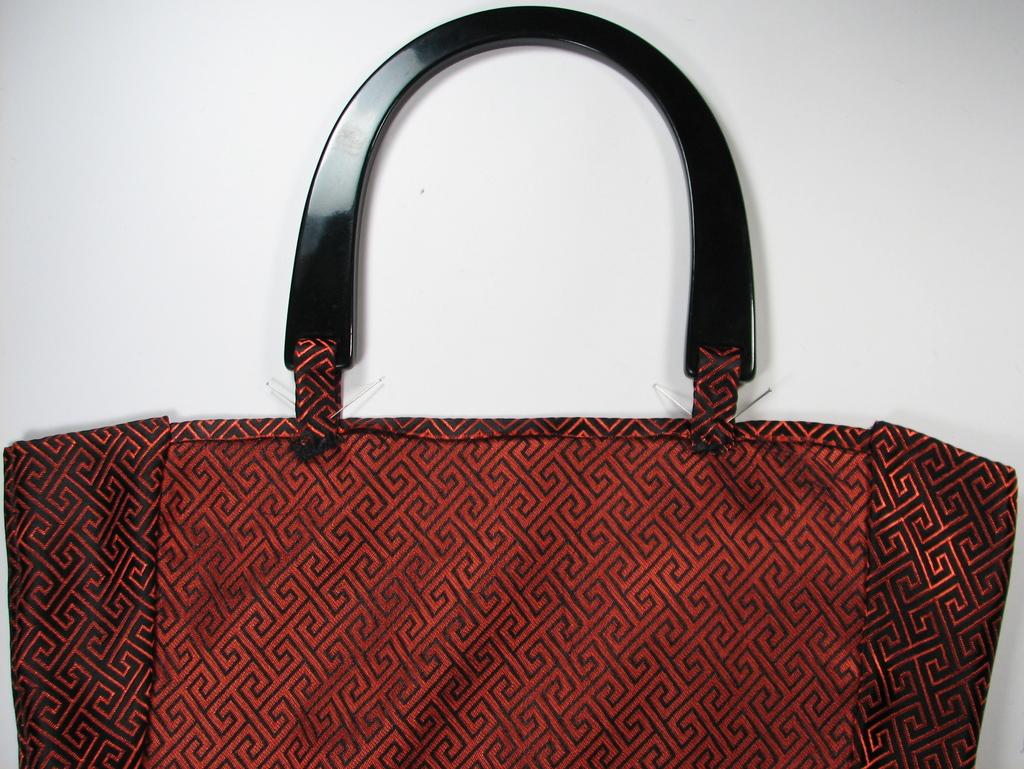What object is present in the picture? There is a handbag in the picture. What is the color of the handbag? The handbag is red in color. Are there any patterns or designs on the handbag? Yes, the handbag has lines on it. What is the color of the handbag's handle? The handbag's handle is black in color. How many bikes are parked next to the handbag in the image? There are no bikes present in the image; it only features a handbag. What type of legs can be seen supporting the handbag in the image? There are no legs visible in the image, as the handbag is likely resting on a surface or held by someone. 